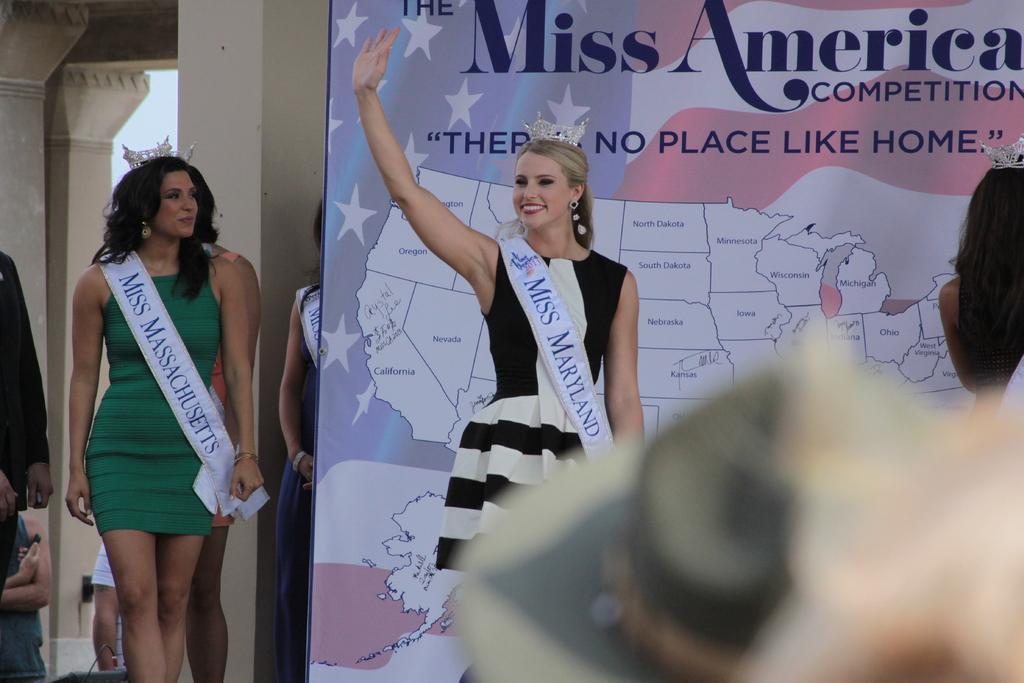Could you give a brief overview of what you see in this image? In this image a woman is wearing a black dress. She is having a crown on her head. Behind her there is a banner having a nap and some text on it. Beside banner there are few persons. Behind them there are few pillars. Right side there is a person having crown on his head. 